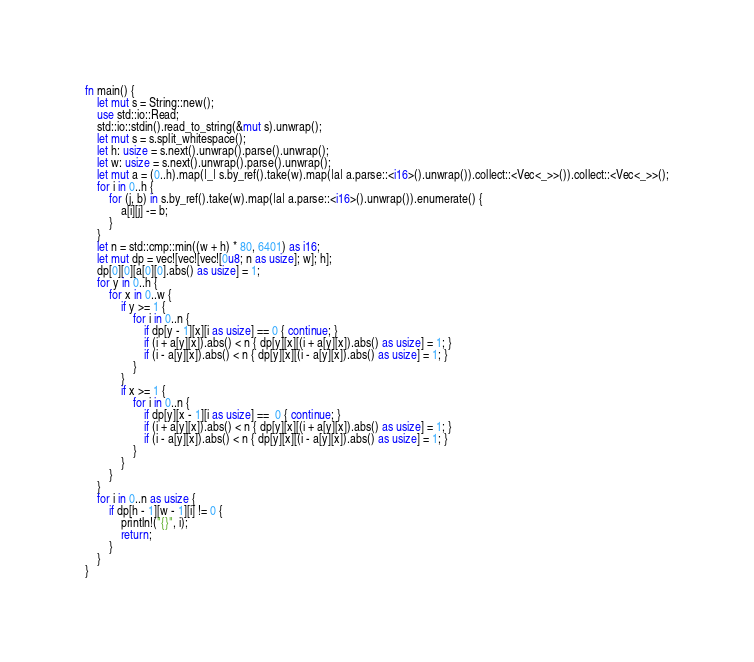Convert code to text. <code><loc_0><loc_0><loc_500><loc_500><_Rust_>fn main() {
	let mut s = String::new();
	use std::io::Read;
	std::io::stdin().read_to_string(&mut s).unwrap();
	let mut s = s.split_whitespace();
	let h: usize = s.next().unwrap().parse().unwrap();
	let w: usize = s.next().unwrap().parse().unwrap();
	let mut a = (0..h).map(|_| s.by_ref().take(w).map(|a| a.parse::<i16>().unwrap()).collect::<Vec<_>>()).collect::<Vec<_>>();
	for i in 0..h {
		for (j, b) in s.by_ref().take(w).map(|a| a.parse::<i16>().unwrap()).enumerate() {
			a[i][j] -= b;
		}
	}
	let n = std::cmp::min((w + h) * 80, 6401) as i16;
	let mut dp = vec![vec![vec![0u8; n as usize]; w]; h];
	dp[0][0][a[0][0].abs() as usize] = 1;
	for y in 0..h {
		for x in 0..w {
			if y >= 1 {
				for i in 0..n {
					if dp[y - 1][x][i as usize] == 0 { continue; }
					if (i + a[y][x]).abs() < n { dp[y][x][(i + a[y][x]).abs() as usize] = 1; }
					if (i - a[y][x]).abs() < n { dp[y][x][(i - a[y][x]).abs() as usize] = 1; }
				}
			}
			if x >= 1 {
				for i in 0..n {
					if dp[y][x - 1][i as usize] ==  0 { continue; }
					if (i + a[y][x]).abs() < n { dp[y][x][(i + a[y][x]).abs() as usize] = 1; }
					if (i - a[y][x]).abs() < n { dp[y][x][(i - a[y][x]).abs() as usize] = 1; }
				}
			}
		}
	}
	for i in 0..n as usize {
		if dp[h - 1][w - 1][i] != 0 {
			println!("{}", i);
			return;
		}
	}
}
</code> 